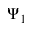Convert formula to latex. <formula><loc_0><loc_0><loc_500><loc_500>\Psi _ { 1 }</formula> 